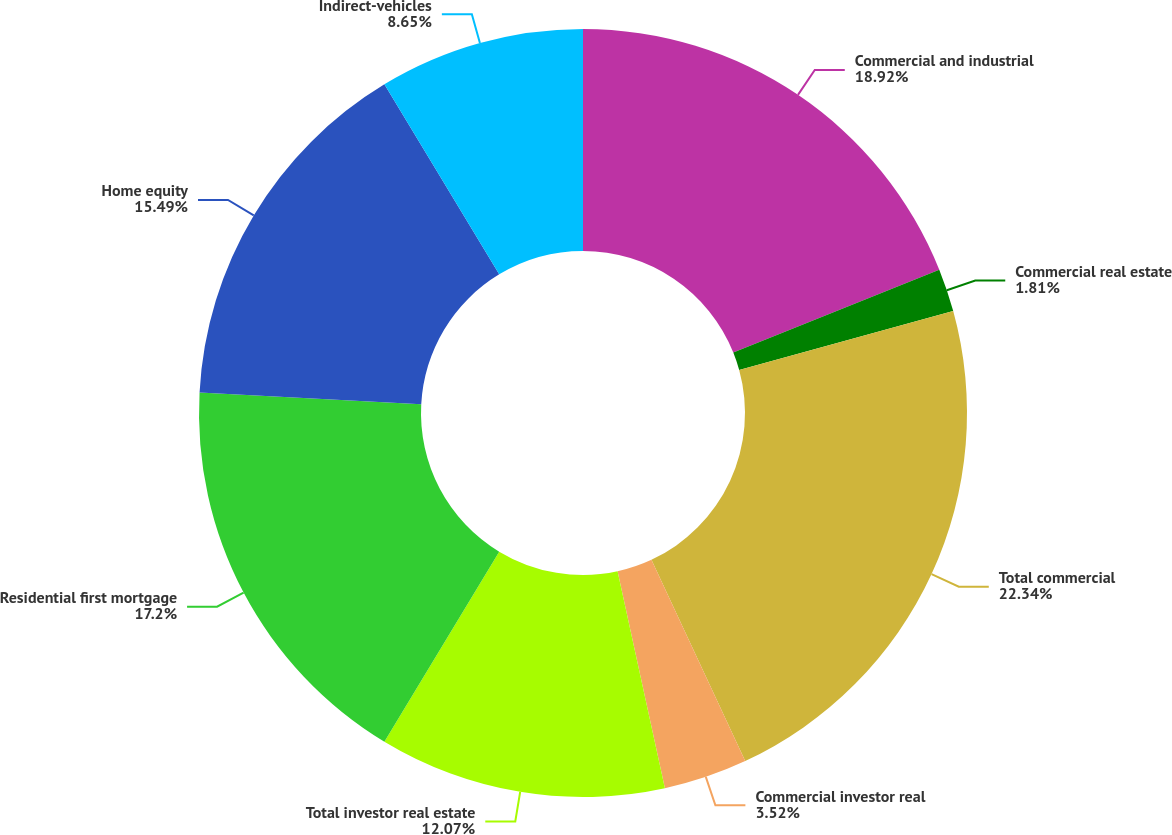<chart> <loc_0><loc_0><loc_500><loc_500><pie_chart><fcel>Commercial and industrial<fcel>Commercial real estate<fcel>Total commercial<fcel>Commercial investor real<fcel>Total investor real estate<fcel>Residential first mortgage<fcel>Home equity<fcel>Indirect-vehicles<nl><fcel>18.91%<fcel>1.81%<fcel>22.33%<fcel>3.52%<fcel>12.07%<fcel>17.2%<fcel>15.49%<fcel>8.65%<nl></chart> 